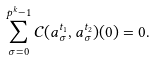<formula> <loc_0><loc_0><loc_500><loc_500>\sum _ { \sigma = 0 } ^ { p ^ { k } - 1 } \mathcal { C } ( a _ { \sigma } ^ { t _ { 1 } } , a _ { \sigma } ^ { t _ { 2 } } ) ( 0 ) = 0 .</formula> 